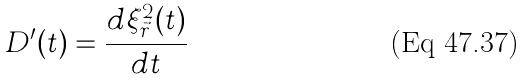Convert formula to latex. <formula><loc_0><loc_0><loc_500><loc_500>D ^ { \prime } ( t ) = \frac { d \xi ^ { 2 } _ { \vec { r } } ( t ) } { d t }</formula> 